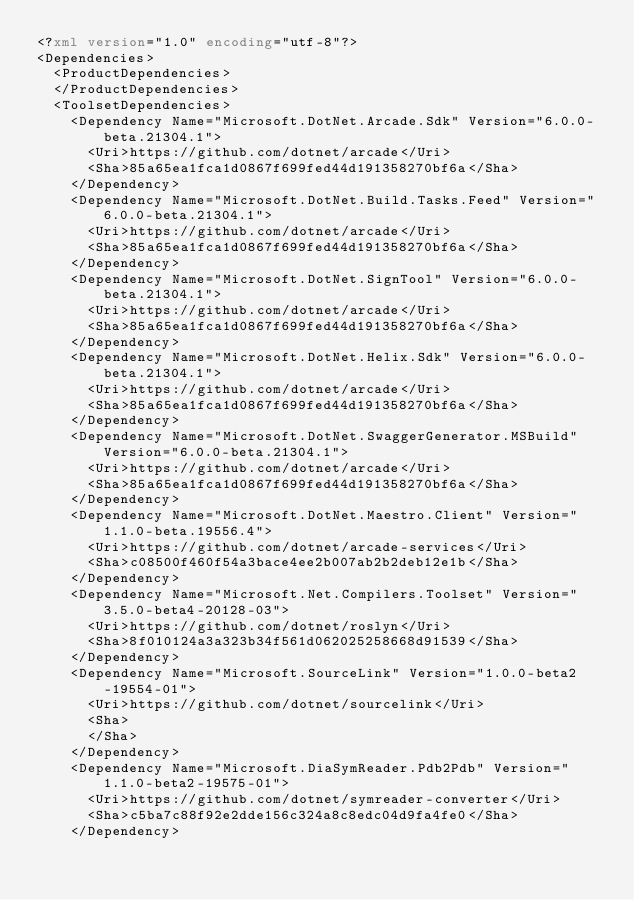<code> <loc_0><loc_0><loc_500><loc_500><_XML_><?xml version="1.0" encoding="utf-8"?>
<Dependencies>
  <ProductDependencies>
  </ProductDependencies>
  <ToolsetDependencies>
    <Dependency Name="Microsoft.DotNet.Arcade.Sdk" Version="6.0.0-beta.21304.1">
      <Uri>https://github.com/dotnet/arcade</Uri>
      <Sha>85a65ea1fca1d0867f699fed44d191358270bf6a</Sha>
    </Dependency>
    <Dependency Name="Microsoft.DotNet.Build.Tasks.Feed" Version="6.0.0-beta.21304.1">
      <Uri>https://github.com/dotnet/arcade</Uri>
      <Sha>85a65ea1fca1d0867f699fed44d191358270bf6a</Sha>
    </Dependency>
    <Dependency Name="Microsoft.DotNet.SignTool" Version="6.0.0-beta.21304.1">
      <Uri>https://github.com/dotnet/arcade</Uri>
      <Sha>85a65ea1fca1d0867f699fed44d191358270bf6a</Sha>
    </Dependency>
    <Dependency Name="Microsoft.DotNet.Helix.Sdk" Version="6.0.0-beta.21304.1">
      <Uri>https://github.com/dotnet/arcade</Uri>
      <Sha>85a65ea1fca1d0867f699fed44d191358270bf6a</Sha>
    </Dependency>
    <Dependency Name="Microsoft.DotNet.SwaggerGenerator.MSBuild" Version="6.0.0-beta.21304.1">
      <Uri>https://github.com/dotnet/arcade</Uri>
      <Sha>85a65ea1fca1d0867f699fed44d191358270bf6a</Sha>
    </Dependency>
    <Dependency Name="Microsoft.DotNet.Maestro.Client" Version="1.1.0-beta.19556.4">
      <Uri>https://github.com/dotnet/arcade-services</Uri>
      <Sha>c08500f460f54a3bace4ee2b007ab2b2deb12e1b</Sha>
    </Dependency>
    <Dependency Name="Microsoft.Net.Compilers.Toolset" Version="3.5.0-beta4-20128-03">
      <Uri>https://github.com/dotnet/roslyn</Uri>
      <Sha>8f010124a3a323b34f561d062025258668d91539</Sha>
    </Dependency>
    <Dependency Name="Microsoft.SourceLink" Version="1.0.0-beta2-19554-01">
      <Uri>https://github.com/dotnet/sourcelink</Uri>
      <Sha>
      </Sha>
    </Dependency>
    <Dependency Name="Microsoft.DiaSymReader.Pdb2Pdb" Version="1.1.0-beta2-19575-01">
      <Uri>https://github.com/dotnet/symreader-converter</Uri>
      <Sha>c5ba7c88f92e2dde156c324a8c8edc04d9fa4fe0</Sha>
    </Dependency></code> 